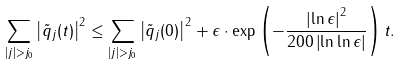<formula> <loc_0><loc_0><loc_500><loc_500>\sum _ { | j | > j _ { 0 } } \left | \tilde { q } _ { j } ( t ) \right | ^ { 2 } \leq \sum _ { | j | > j _ { 0 } } \left | \tilde { q } _ { j } ( 0 ) \right | ^ { 2 } + \epsilon \cdot \exp \left ( - \frac { \left | \ln \epsilon \right | ^ { 2 } } { 2 0 0 \left | \ln \ln \epsilon \right | } \right ) t .</formula> 